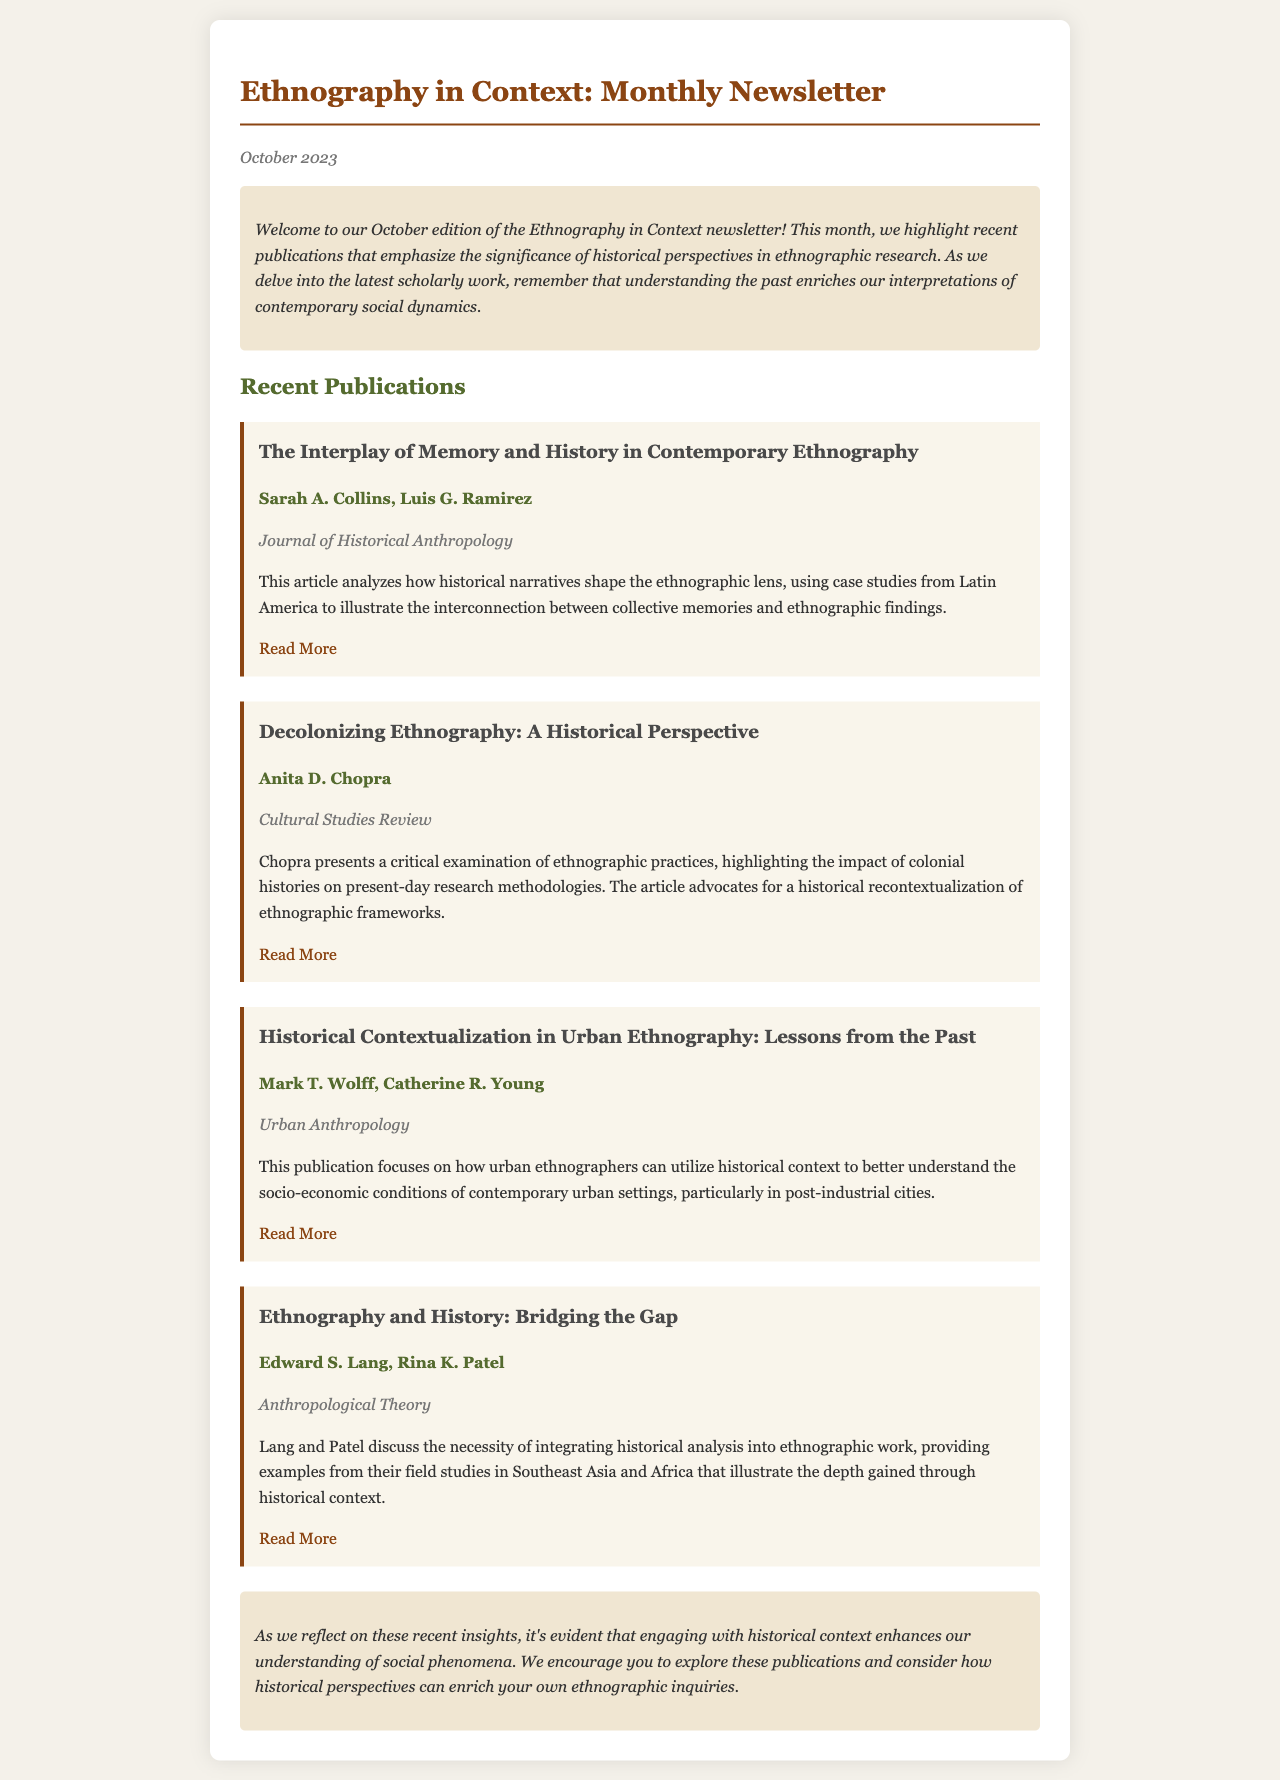What is the title of the newsletter? The title is displayed prominently at the top of the document.
Answer: Ethnography in Context: Monthly Newsletter Who are the authors of the article "Decolonizing Ethnography: A Historical Perspective"? The authors' names are listed directly under the title of the corresponding publication.
Answer: Anita D. Chopra Which journal published the article "The Interplay of Memory and History in Contemporary Ethnography"? The journal name is provided in italics right below the authors' names for each publication.
Answer: Journal of Historical Anthropology What date was this newsletter published? The publication date is shown in italics at the beginning of the newsletter.
Answer: October 2023 How many publications are highlighted in the newsletter? The number of publications can be counted from the sections listing them, which includes a distinct heading for each.
Answer: Four What is the theme emphasized in the recent publications discussed in the newsletter? The theme is explicitly stated in the introductory paragraph.
Answer: Historical perspectives What is one of the key focuses of the article by Mark T. Wolff and Catherine R. Young? The key focus is mentioned within the brief description of each publication.
Answer: Historical contextualization in urban ethnography What does the conclusion of the newsletter encourage readers to do? The conclusion provides a call to action based on the themes discussed in the newsletter.
Answer: Explore these publications What color is used for the title of the newsletter? The color can be identified from the styling applied to the title within the document.
Answer: Brown 